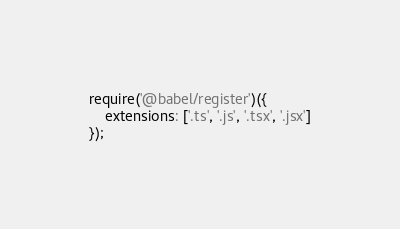<code> <loc_0><loc_0><loc_500><loc_500><_JavaScript_>require('@babel/register')({
	extensions: ['.ts', '.js', '.tsx', '.jsx']
});
</code> 